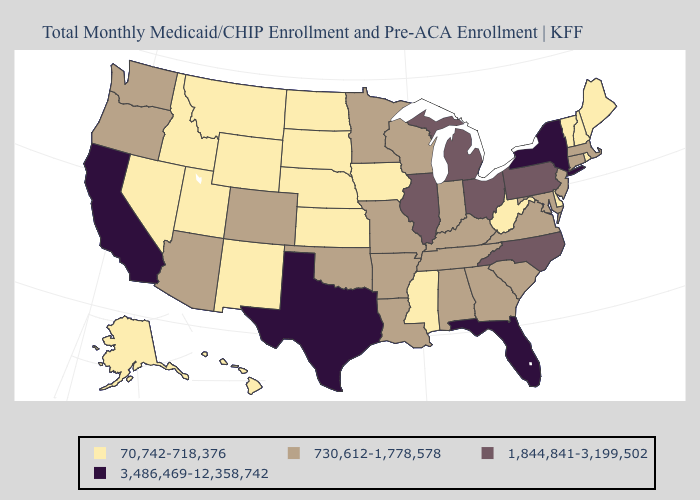What is the highest value in the USA?
Answer briefly. 3,486,469-12,358,742. Does the first symbol in the legend represent the smallest category?
Give a very brief answer. Yes. What is the value of Missouri?
Be succinct. 730,612-1,778,578. What is the value of Oklahoma?
Be succinct. 730,612-1,778,578. Does New Jersey have the lowest value in the Northeast?
Be succinct. No. What is the value of Massachusetts?
Short answer required. 730,612-1,778,578. How many symbols are there in the legend?
Concise answer only. 4. What is the value of Rhode Island?
Write a very short answer. 70,742-718,376. Which states have the lowest value in the West?
Keep it brief. Alaska, Hawaii, Idaho, Montana, Nevada, New Mexico, Utah, Wyoming. What is the value of Indiana?
Keep it brief. 730,612-1,778,578. Among the states that border Oklahoma , which have the lowest value?
Keep it brief. Kansas, New Mexico. Name the states that have a value in the range 730,612-1,778,578?
Short answer required. Alabama, Arizona, Arkansas, Colorado, Connecticut, Georgia, Indiana, Kentucky, Louisiana, Maryland, Massachusetts, Minnesota, Missouri, New Jersey, Oklahoma, Oregon, South Carolina, Tennessee, Virginia, Washington, Wisconsin. What is the value of Wisconsin?
Quick response, please. 730,612-1,778,578. Which states have the lowest value in the West?
Write a very short answer. Alaska, Hawaii, Idaho, Montana, Nevada, New Mexico, Utah, Wyoming. Name the states that have a value in the range 1,844,841-3,199,502?
Quick response, please. Illinois, Michigan, North Carolina, Ohio, Pennsylvania. 